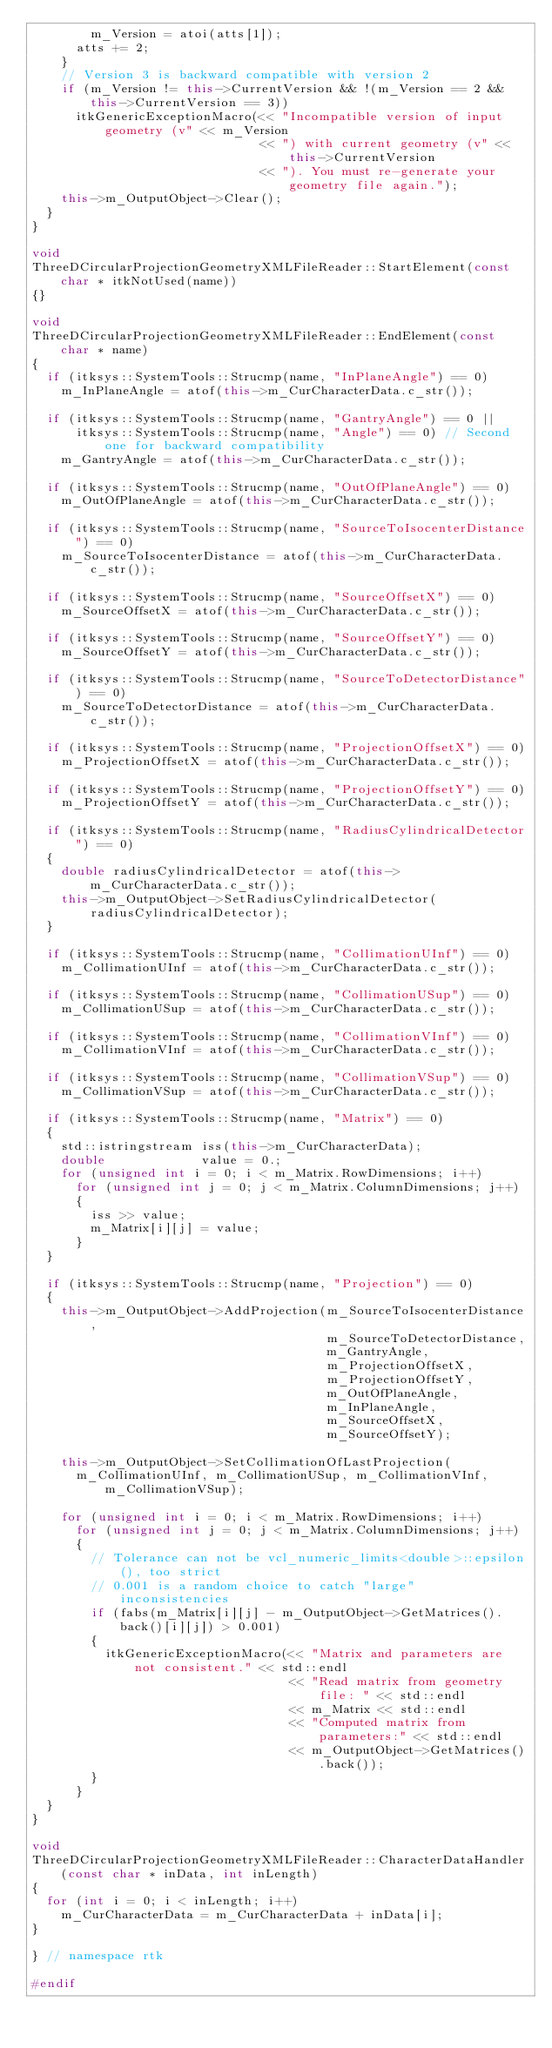Convert code to text. <code><loc_0><loc_0><loc_500><loc_500><_C++_>        m_Version = atoi(atts[1]);
      atts += 2;
    }
    // Version 3 is backward compatible with version 2
    if (m_Version != this->CurrentVersion && !(m_Version == 2 && this->CurrentVersion == 3))
      itkGenericExceptionMacro(<< "Incompatible version of input geometry (v" << m_Version
                               << ") with current geometry (v" << this->CurrentVersion
                               << "). You must re-generate your geometry file again.");
    this->m_OutputObject->Clear();
  }
}

void
ThreeDCircularProjectionGeometryXMLFileReader::StartElement(const char * itkNotUsed(name))
{}

void
ThreeDCircularProjectionGeometryXMLFileReader::EndElement(const char * name)
{
  if (itksys::SystemTools::Strucmp(name, "InPlaneAngle") == 0)
    m_InPlaneAngle = atof(this->m_CurCharacterData.c_str());

  if (itksys::SystemTools::Strucmp(name, "GantryAngle") == 0 ||
      itksys::SystemTools::Strucmp(name, "Angle") == 0) // Second one for backward compatibility
    m_GantryAngle = atof(this->m_CurCharacterData.c_str());

  if (itksys::SystemTools::Strucmp(name, "OutOfPlaneAngle") == 0)
    m_OutOfPlaneAngle = atof(this->m_CurCharacterData.c_str());

  if (itksys::SystemTools::Strucmp(name, "SourceToIsocenterDistance") == 0)
    m_SourceToIsocenterDistance = atof(this->m_CurCharacterData.c_str());

  if (itksys::SystemTools::Strucmp(name, "SourceOffsetX") == 0)
    m_SourceOffsetX = atof(this->m_CurCharacterData.c_str());

  if (itksys::SystemTools::Strucmp(name, "SourceOffsetY") == 0)
    m_SourceOffsetY = atof(this->m_CurCharacterData.c_str());

  if (itksys::SystemTools::Strucmp(name, "SourceToDetectorDistance") == 0)
    m_SourceToDetectorDistance = atof(this->m_CurCharacterData.c_str());

  if (itksys::SystemTools::Strucmp(name, "ProjectionOffsetX") == 0)
    m_ProjectionOffsetX = atof(this->m_CurCharacterData.c_str());

  if (itksys::SystemTools::Strucmp(name, "ProjectionOffsetY") == 0)
    m_ProjectionOffsetY = atof(this->m_CurCharacterData.c_str());

  if (itksys::SystemTools::Strucmp(name, "RadiusCylindricalDetector") == 0)
  {
    double radiusCylindricalDetector = atof(this->m_CurCharacterData.c_str());
    this->m_OutputObject->SetRadiusCylindricalDetector(radiusCylindricalDetector);
  }

  if (itksys::SystemTools::Strucmp(name, "CollimationUInf") == 0)
    m_CollimationUInf = atof(this->m_CurCharacterData.c_str());

  if (itksys::SystemTools::Strucmp(name, "CollimationUSup") == 0)
    m_CollimationUSup = atof(this->m_CurCharacterData.c_str());

  if (itksys::SystemTools::Strucmp(name, "CollimationVInf") == 0)
    m_CollimationVInf = atof(this->m_CurCharacterData.c_str());

  if (itksys::SystemTools::Strucmp(name, "CollimationVSup") == 0)
    m_CollimationVSup = atof(this->m_CurCharacterData.c_str());

  if (itksys::SystemTools::Strucmp(name, "Matrix") == 0)
  {
    std::istringstream iss(this->m_CurCharacterData);
    double             value = 0.;
    for (unsigned int i = 0; i < m_Matrix.RowDimensions; i++)
      for (unsigned int j = 0; j < m_Matrix.ColumnDimensions; j++)
      {
        iss >> value;
        m_Matrix[i][j] = value;
      }
  }

  if (itksys::SystemTools::Strucmp(name, "Projection") == 0)
  {
    this->m_OutputObject->AddProjection(m_SourceToIsocenterDistance,
                                        m_SourceToDetectorDistance,
                                        m_GantryAngle,
                                        m_ProjectionOffsetX,
                                        m_ProjectionOffsetY,
                                        m_OutOfPlaneAngle,
                                        m_InPlaneAngle,
                                        m_SourceOffsetX,
                                        m_SourceOffsetY);

    this->m_OutputObject->SetCollimationOfLastProjection(
      m_CollimationUInf, m_CollimationUSup, m_CollimationVInf, m_CollimationVSup);

    for (unsigned int i = 0; i < m_Matrix.RowDimensions; i++)
      for (unsigned int j = 0; j < m_Matrix.ColumnDimensions; j++)
      {
        // Tolerance can not be vcl_numeric_limits<double>::epsilon(), too strict
        // 0.001 is a random choice to catch "large" inconsistencies
        if (fabs(m_Matrix[i][j] - m_OutputObject->GetMatrices().back()[i][j]) > 0.001)
        {
          itkGenericExceptionMacro(<< "Matrix and parameters are not consistent." << std::endl
                                   << "Read matrix from geometry file: " << std::endl
                                   << m_Matrix << std::endl
                                   << "Computed matrix from parameters:" << std::endl
                                   << m_OutputObject->GetMatrices().back());
        }
      }
  }
}

void
ThreeDCircularProjectionGeometryXMLFileReader::CharacterDataHandler(const char * inData, int inLength)
{
  for (int i = 0; i < inLength; i++)
    m_CurCharacterData = m_CurCharacterData + inData[i];
}

} // namespace rtk

#endif
</code> 